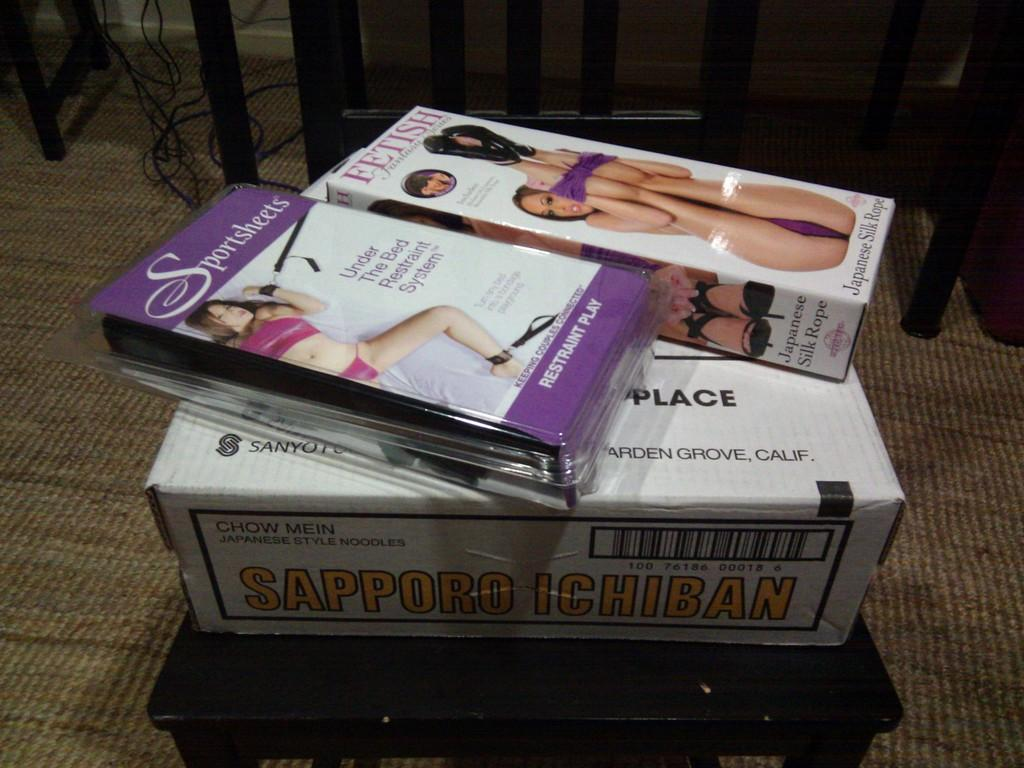<image>
Share a concise interpretation of the image provided. Two adult video tapes placed on top of a "Sapporo Ichiban" box. 